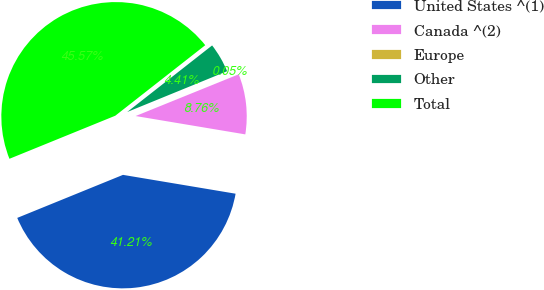Convert chart. <chart><loc_0><loc_0><loc_500><loc_500><pie_chart><fcel>United States ^(1)<fcel>Canada ^(2)<fcel>Europe<fcel>Other<fcel>Total<nl><fcel>41.21%<fcel>8.76%<fcel>0.05%<fcel>4.41%<fcel>45.57%<nl></chart> 